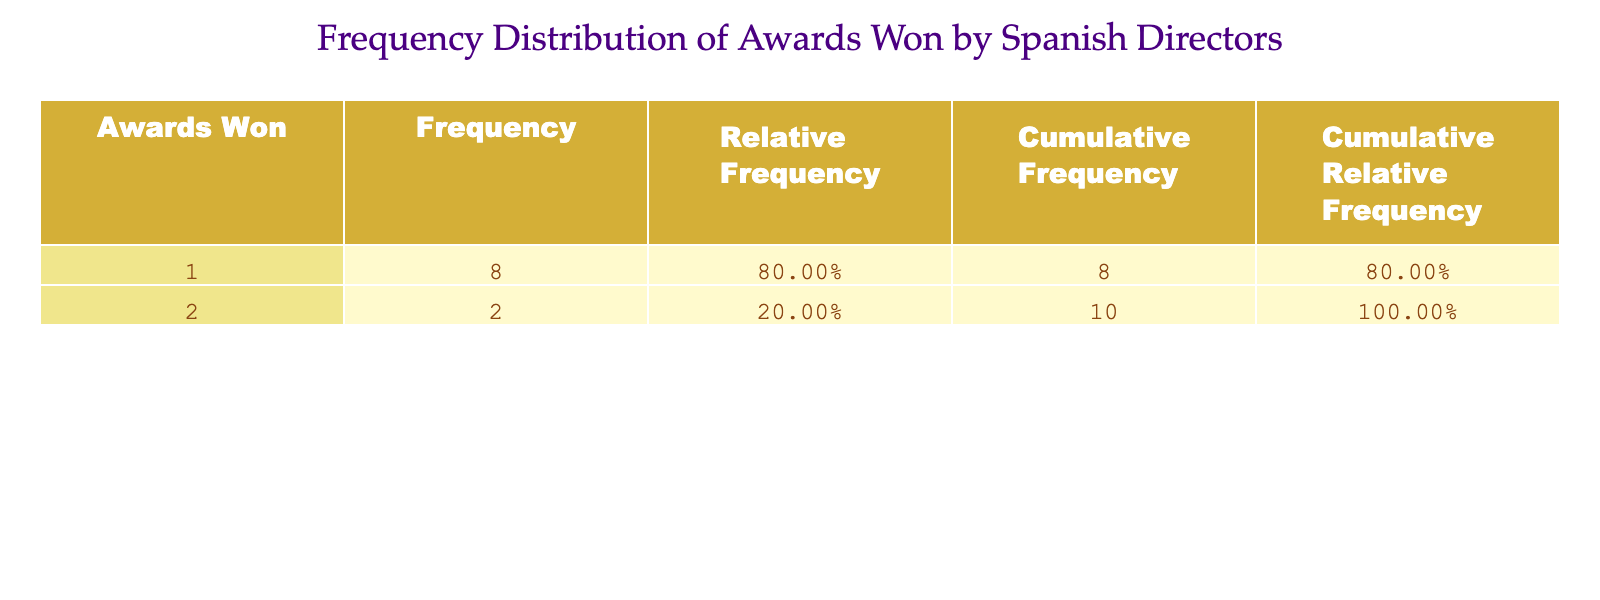What is the most common number of awards won by Spanish directors? The table lists the frequency of awards won. By looking at the "Frequency" column, we can see that the highest frequency corresponds to "1 award," which has a frequency of 6.
Answer: 1 award How many directors won 2 awards? The table indicates that "2 awards" appears only once in the "Frequency" column with a frequency of 2. So, there are 2 directors who won 2 awards.
Answer: 2 directors What is the cumulative frequency of directors who won 1 award? To find this, we need to look at the frequency of "1 award," which is 6, and since it's the first entry, the cumulative frequency is also 6.
Answer: 6 Did any director win more than 2 awards? The table shows that the highest number of awards won is 2, thus no director has won more than 2 awards.
Answer: No What percentage of directors won 1 or fewer awards? We can see that the frequency of directors who won "1 award" is 6, and for "0 awards," it is 0. Therefore, the total is 6. The total number of directors is 10. So the percentage is (6/10) * 100 = 60%.
Answer: 60% What is the cumulative relative frequency for directors who won 2 awards? From the table, the relative frequency of "2 awards" is calculated as its frequency (2) divided by the total number of directors (10), which is 0.20. The cumulative relative frequency for 1 award (0.60) is added to this, giving us 0.20 + 0.60 = 0.80.
Answer: 0.80 How many award-winning films are represented in the table? To find this, we can count the unique directors listed in the table, each representing one film. There are 10 directors listed, hence there are 10 award-winning films represented.
Answer: 10 films Is the frequency of awards won by directors evenly distributed? Looking at the frequency values (1: 6, 2: 2), we see there's a significant difference, with many directors winning only 1 award. Thus, it is not evenly distributed.
Answer: No What is the frequency of directors who won 0 awards? The table does not explicitly mention "0 awards," suggesting that all directors listed have won at least 1 award. Thus, the frequency for "0 awards" is 0.
Answer: 0 